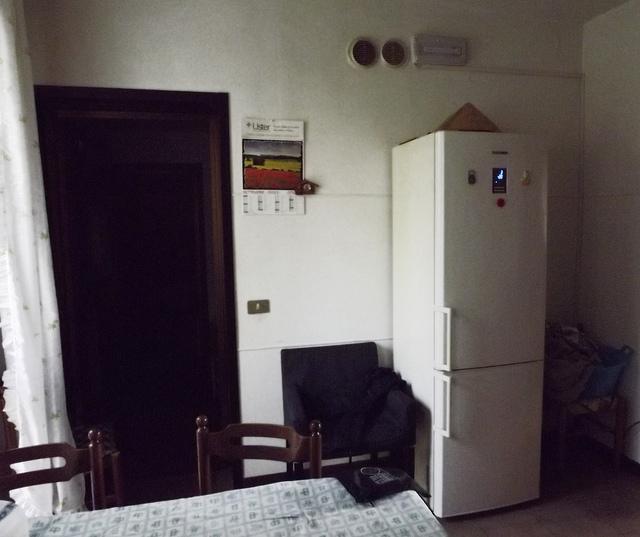How many chairs are there?
Give a very brief answer. 4. How many dining tables can you see?
Give a very brief answer. 1. 